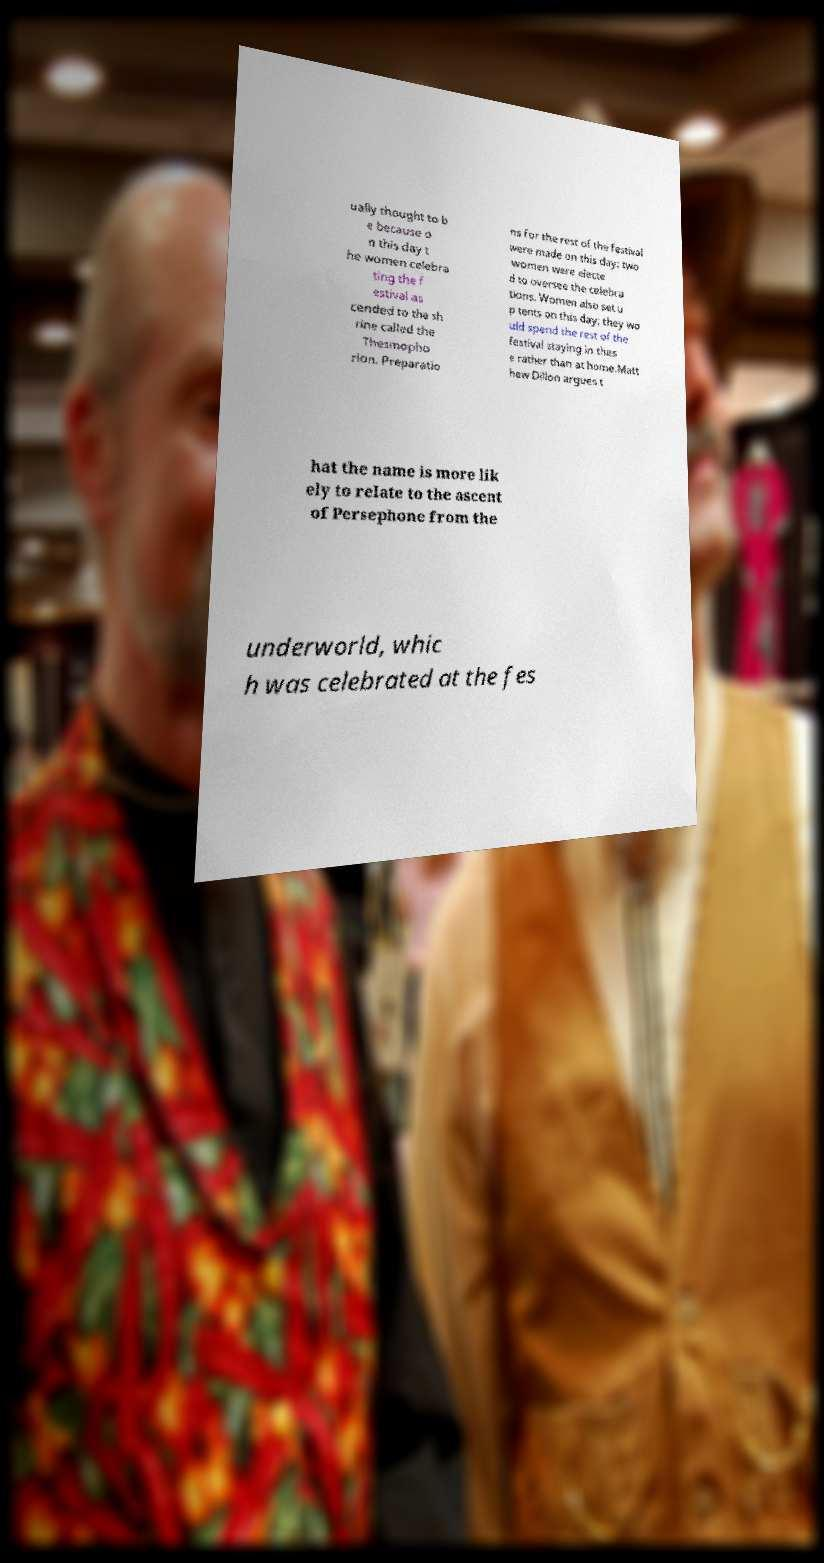Can you read and provide the text displayed in the image?This photo seems to have some interesting text. Can you extract and type it out for me? ually thought to b e because o n this day t he women celebra ting the f estival as cended to the sh rine called the Thesmopho rion. Preparatio ns for the rest of the festival were made on this day: two women were electe d to oversee the celebra tions. Women also set u p tents on this day; they wo uld spend the rest of the festival staying in thes e rather than at home.Matt hew Dillon argues t hat the name is more lik ely to relate to the ascent of Persephone from the underworld, whic h was celebrated at the fes 